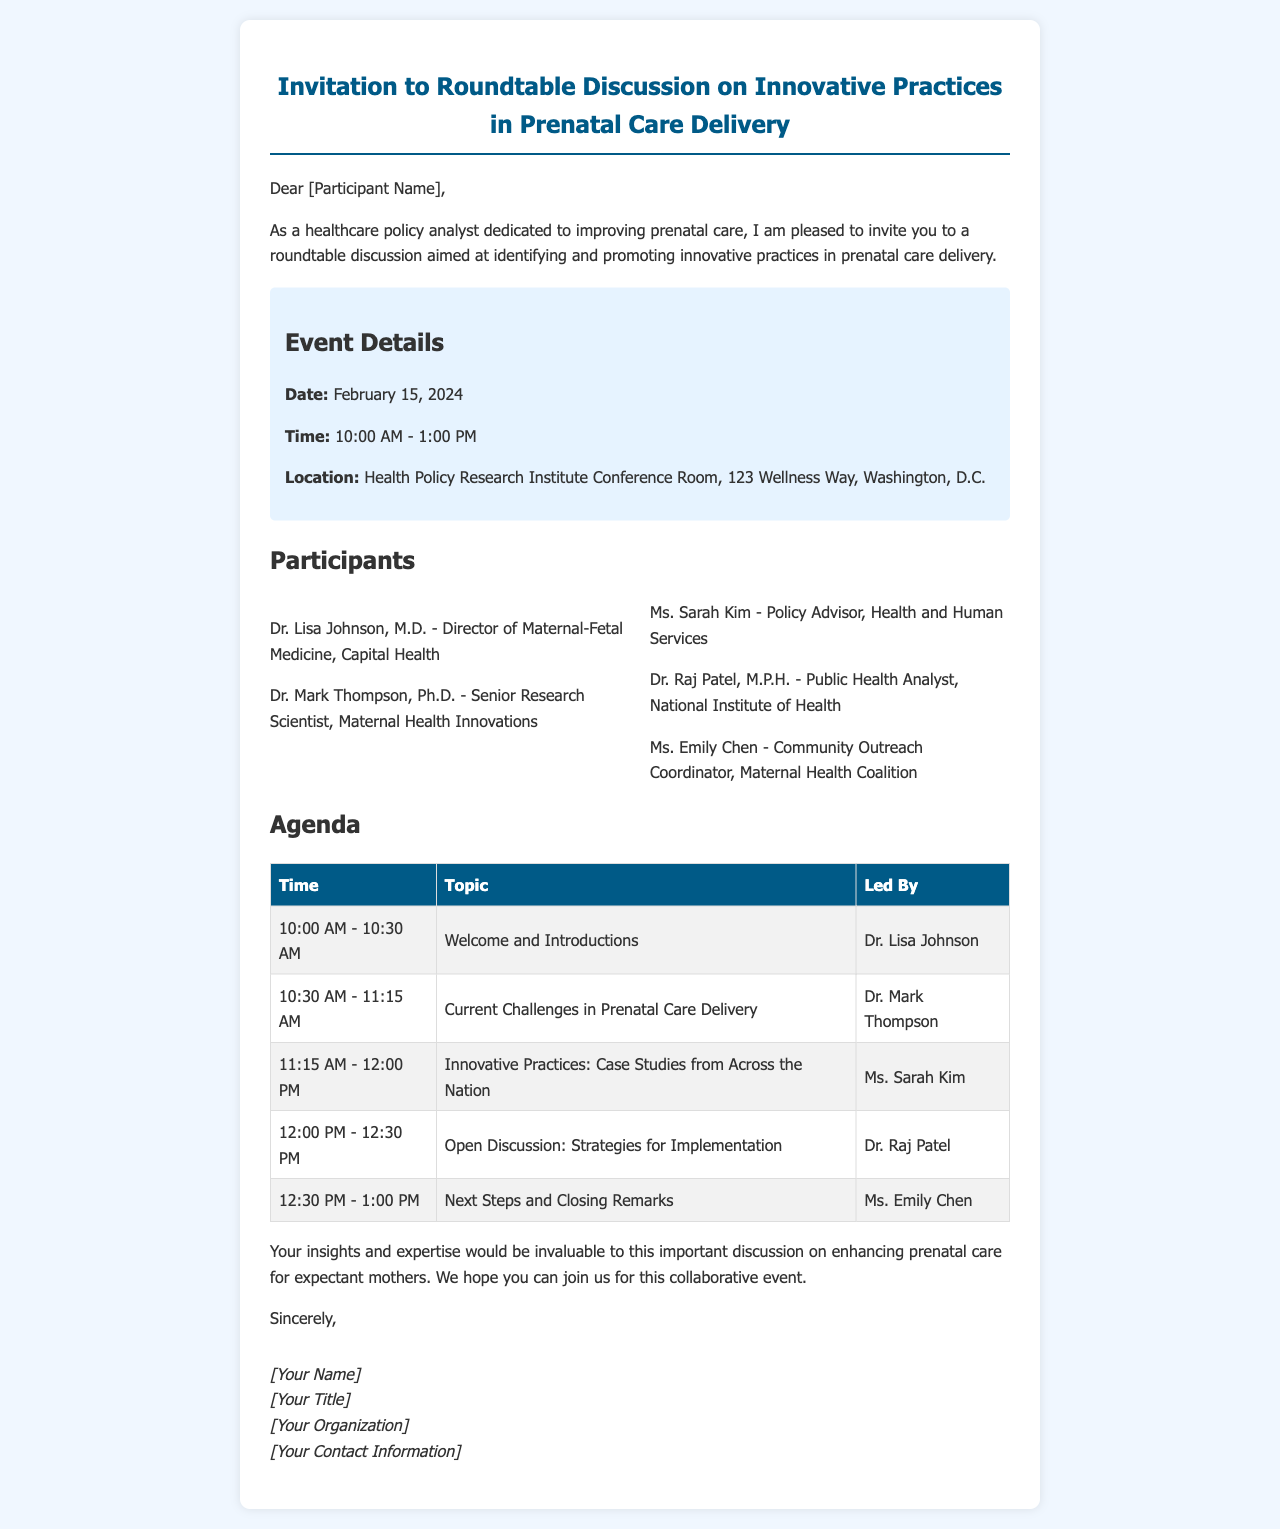What is the date of the event? The date of the event is mentioned in the event details section in the document.
Answer: February 15, 2024 Who is leading the discussion on current challenges in prenatal care delivery? This information is found in the agenda section of the document, which lists who will lead each topic.
Answer: Dr. Mark Thompson What is the location of the roundtable discussion? The location is clearly stated in the event details section.
Answer: Health Policy Research Institute Conference Room, 123 Wellness Way, Washington, D.C How long is the roundtable discussion scheduled to last? The duration can be calculated based on the start and end times provided in the event details section.
Answer: 3 hours Who will lead the session on "Innovative Practices: Case Studies from Across the Nation"? This is specified in the agenda section, providing the name of the person leading that topic.
Answer: Ms. Sarah Kim What type of discussion is scheduled for 12:00 PM? The agenda contains specific topics for each time slot, detailing the nature of the discussion at that time.
Answer: Open Discussion: Strategies for Implementation How many participants are listed in the document? The number of participants can be counted from the participants section.
Answer: 5 participants What is the time for Welcome and Introductions? This is found in the agenda table under the respective time slot.
Answer: 10:00 AM - 10:30 AM Who signed the letter? The signature section of the document indicates the author but leaves placeholders for their details.
Answer: [Your Name] 